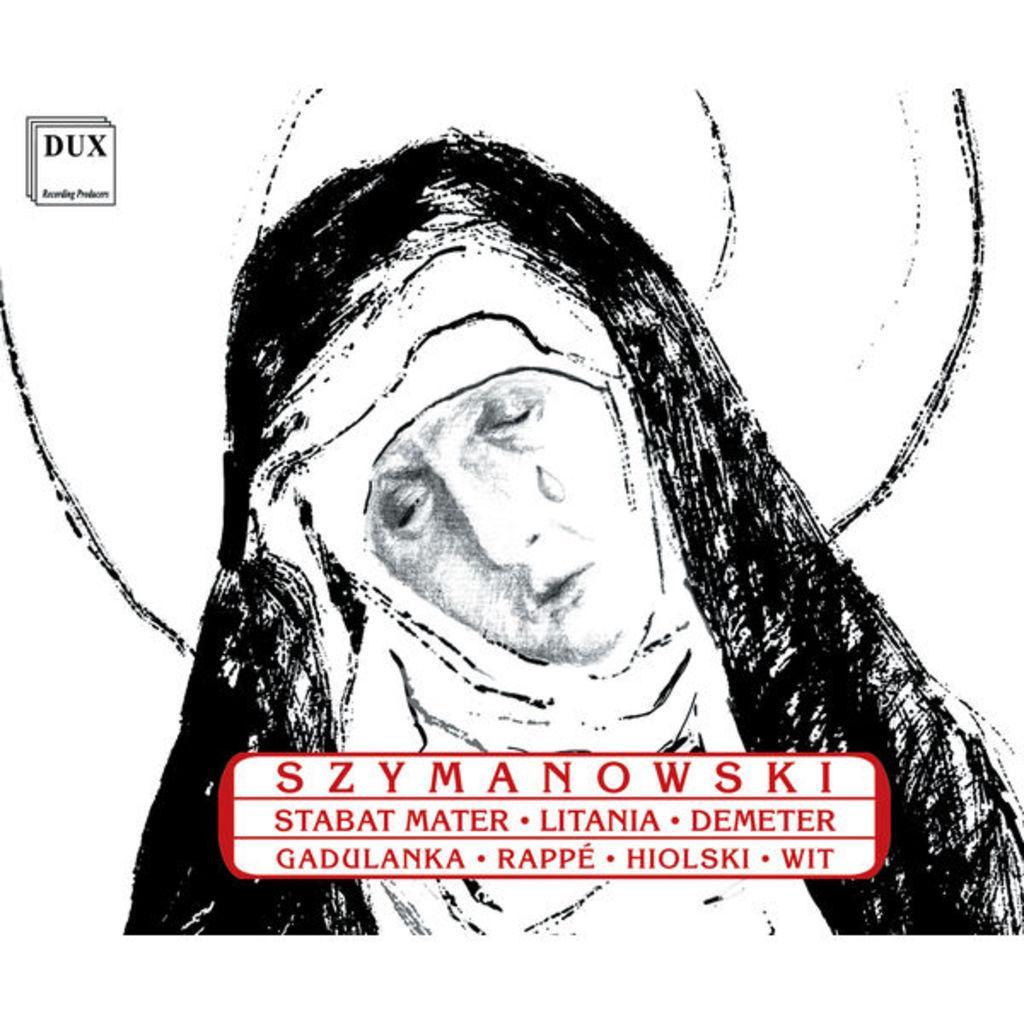In one or two sentences, can you explain what this image depicts? In the picture we can see a painting of a woman bending her head towards the left and she is crying and on her we can see a black colored cloth. 